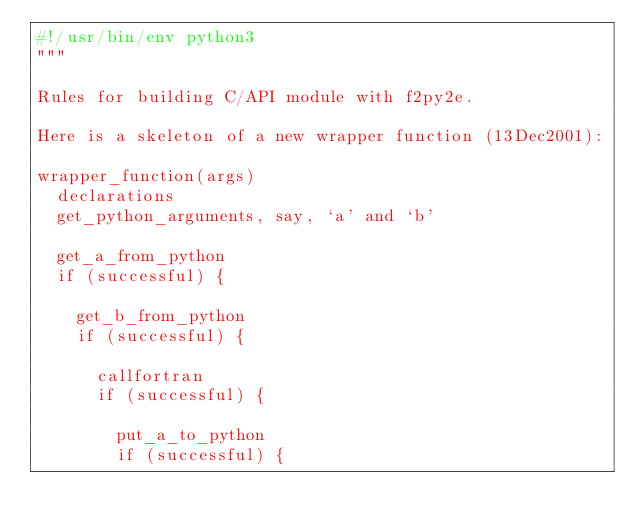<code> <loc_0><loc_0><loc_500><loc_500><_Python_>#!/usr/bin/env python3
"""

Rules for building C/API module with f2py2e.

Here is a skeleton of a new wrapper function (13Dec2001):

wrapper_function(args)
  declarations
  get_python_arguments, say, `a' and `b'

  get_a_from_python
  if (successful) {

    get_b_from_python
    if (successful) {

      callfortran
      if (successful) {

        put_a_to_python
        if (successful) {
</code> 